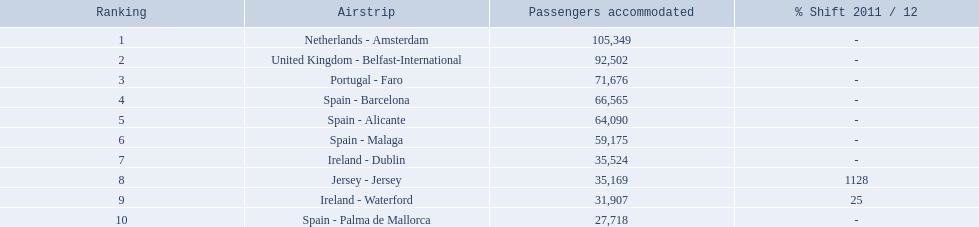How many passengers did the united kingdom handle? 92,502. Who handled more passengers than this? Netherlands - Amsterdam. Which airports are in europe? Netherlands - Amsterdam, United Kingdom - Belfast-International, Portugal - Faro, Spain - Barcelona, Spain - Alicante, Spain - Malaga, Ireland - Dublin, Ireland - Waterford, Spain - Palma de Mallorca. Which one is from portugal? Portugal - Faro. 